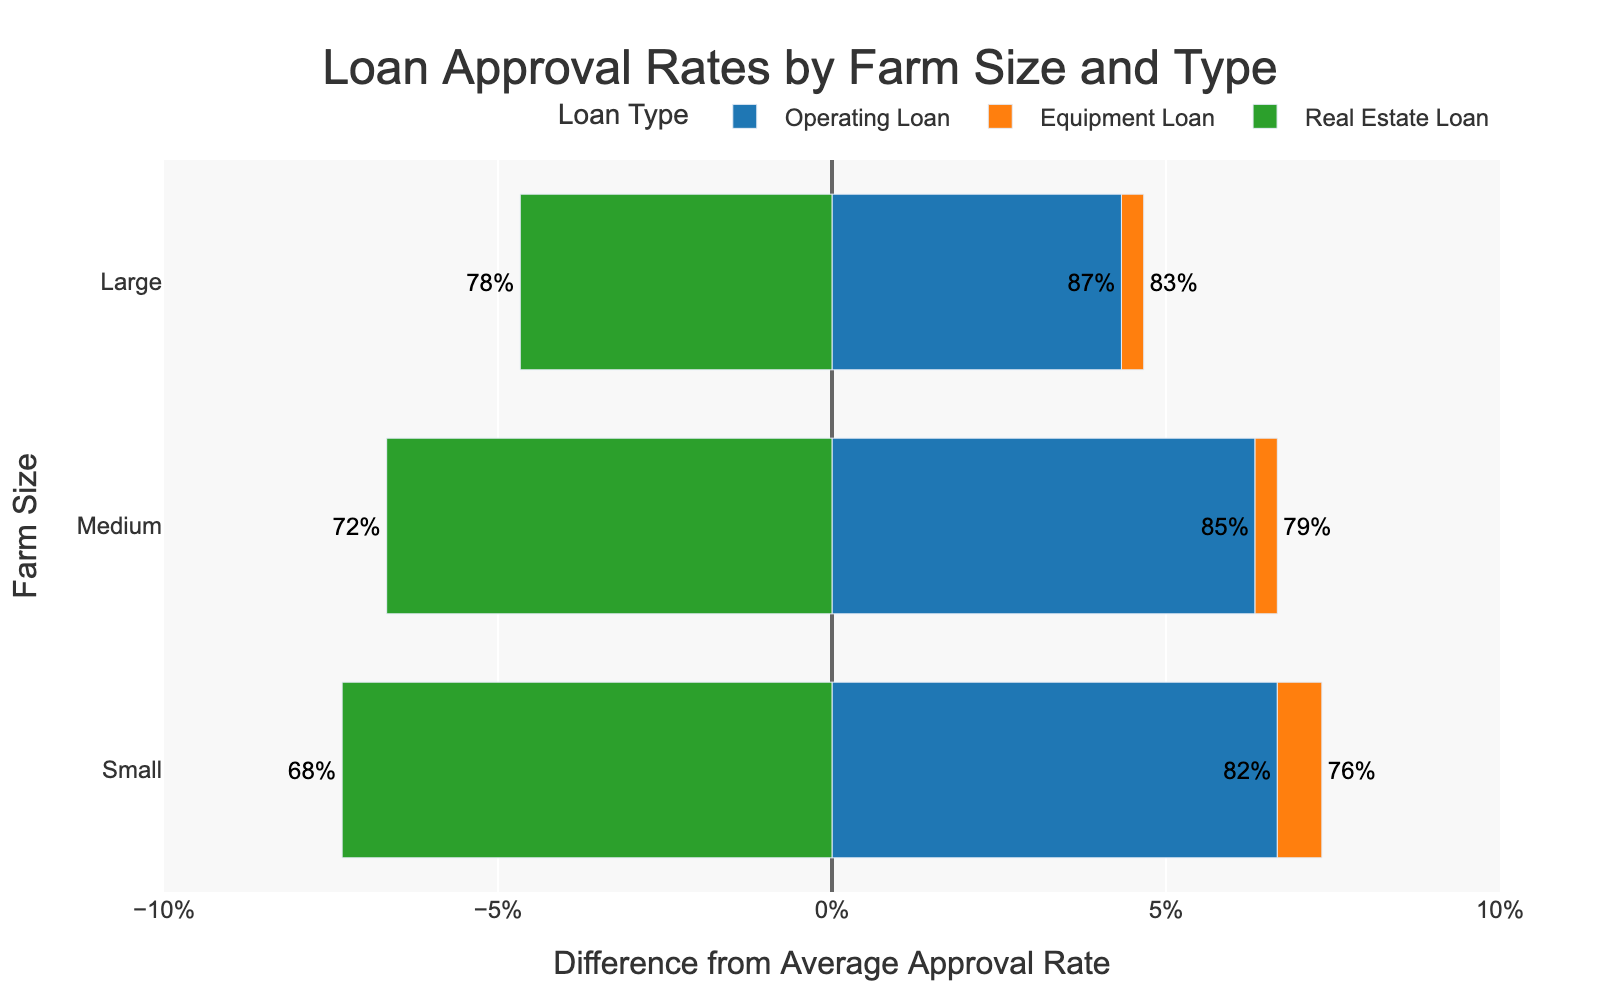What is the approval rate for medium farm size operating loans? Find the bar representing "Medium" farm size and "Operating Loan", hover over it to see its approval rate of 85%.
Answer: 85% How does the approval rate of small farm size equipment loans compare to large farm size equipment loans? Locate the bars for "Small" and "Large" farm sizes under "Equipment Loan", compare their approval rates, which are 76% and 83% respectively.
Answer: Large farms have a higher approval rate Which farm size has the highest approval rate for real estate loans? Identify the bars associated with "Real Estate Loan" for all farm sizes and compare their approval rates. The large farm size has the highest approval rate of 78%.
Answer: Large farms What is the difference between the approval rates of medium farm size equipment loans and real estate loans? Locate the bars for "Medium" farm size under "Equipment Loan" and "Real Estate Loan," compare their approval rates (79% and 72%), and calculate the difference: 79% - 72% = 7%.
Answer: 7% Which loan type has the lowest approval rate for small farms? Identify the bars corresponding to "Small" farm size for different loan types and compare their approval rates. The "Real Estate Loan" has the lowest rate at 68%.
Answer: Real Estate Loan Calculate the average approval rate of all loan types for small farms. Sum the approval rates for "Small" farm size (82% + 76% + 68%) and divide by the number of loan types (3): (82% + 76% + 68%) / 3 = 75.33%.
Answer: 75.33% What is the visual color associated with operating loans? Refer to the legend to see the color used for "Operating Loan". It is blue.
Answer: Blue Compare the height of the bars for small and large farms in the equipment loan category. Visually observe the length of the bars for "Small" and "Large" farm sizes under "Equipment Loan". The bar for "Large" farm size is longer.
Answer: Large farms What is the general trend of loan approval rates as farm size increases? Assess the bar lengths across all loan types from "Small" to "Medium" to "Large" farm sizes and note that they generally increase.
Answer: Increase 